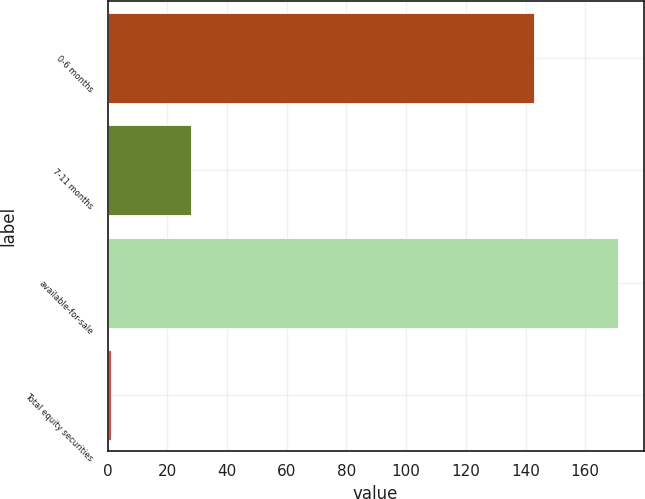<chart> <loc_0><loc_0><loc_500><loc_500><bar_chart><fcel>0-6 months<fcel>7-11 months<fcel>available-for-sale<fcel>Total equity securities<nl><fcel>143<fcel>28<fcel>171<fcel>1<nl></chart> 